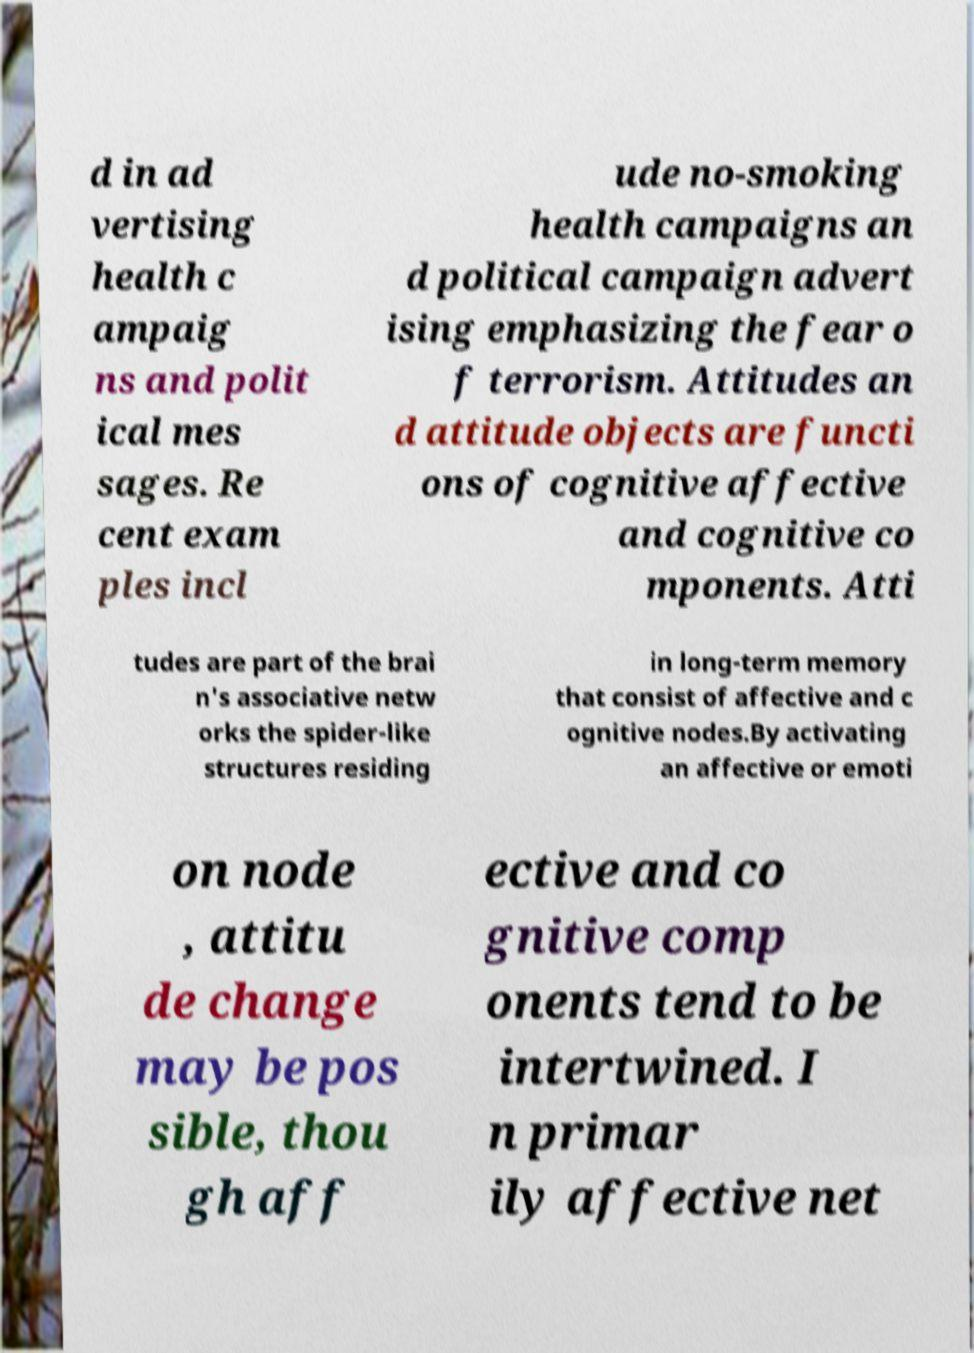Please identify and transcribe the text found in this image. d in ad vertising health c ampaig ns and polit ical mes sages. Re cent exam ples incl ude no-smoking health campaigns an d political campaign advert ising emphasizing the fear o f terrorism. Attitudes an d attitude objects are functi ons of cognitive affective and cognitive co mponents. Atti tudes are part of the brai n's associative netw orks the spider-like structures residing in long-term memory that consist of affective and c ognitive nodes.By activating an affective or emoti on node , attitu de change may be pos sible, thou gh aff ective and co gnitive comp onents tend to be intertwined. I n primar ily affective net 